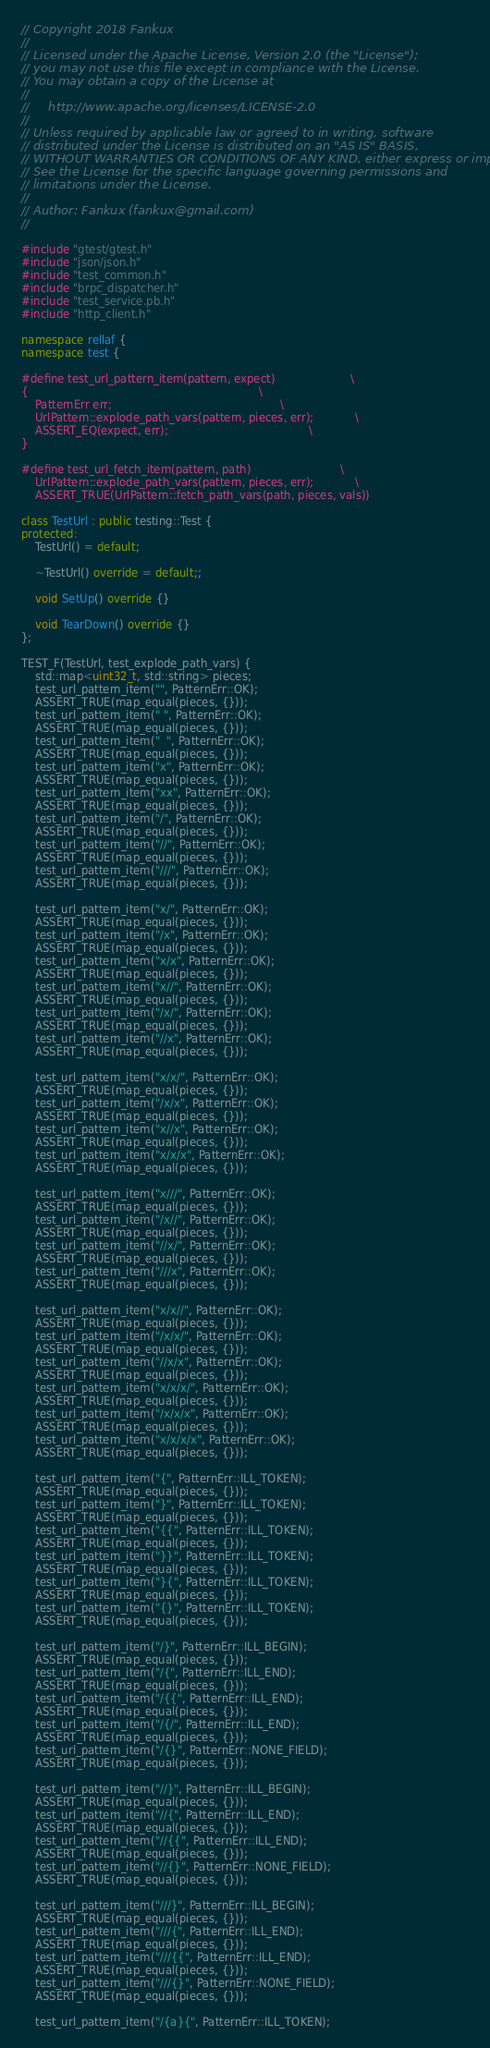<code> <loc_0><loc_0><loc_500><loc_500><_C++_>// Copyright 2018 Fankux
//
// Licensed under the Apache License, Version 2.0 (the "License");
// you may not use this file except in compliance with the License.
// You may obtain a copy of the License at
//
//     http://www.apache.org/licenses/LICENSE-2.0
//
// Unless required by applicable law or agreed to in writing, software
// distributed under the License is distributed on an "AS IS" BASIS,
// WITHOUT WARRANTIES OR CONDITIONS OF ANY KIND, either express or implied.
// See the License for the specific language governing permissions and
// limitations under the License.
//
// Author: Fankux (fankux@gmail.com)
//

#include "gtest/gtest.h"
#include "json/json.h"
#include "test_common.h"
#include "brpc_dispatcher.h"
#include "test_service.pb.h"
#include "http_client.h"

namespace rellaf {
namespace test {

#define test_url_pattern_item(pattern, expect)                      \
{                                                                   \
    PatternErr err;                                                 \
    UrlPattern::explode_path_vars(pattern, pieces, err);            \
    ASSERT_EQ(expect, err);                                         \
}

#define test_url_fetch_item(pattern, path)                          \
    UrlPattern::explode_path_vars(pattern, pieces, err);            \
    ASSERT_TRUE(UrlPattern::fetch_path_vars(path, pieces, vals))

class TestUrl : public testing::Test {
protected:
    TestUrl() = default;

    ~TestUrl() override = default;;

    void SetUp() override {}

    void TearDown() override {}
};

TEST_F(TestUrl, test_explode_path_vars) {
    std::map<uint32_t, std::string> pieces;
    test_url_pattern_item("", PatternErr::OK);
    ASSERT_TRUE(map_equal(pieces, {}));
    test_url_pattern_item(" ", PatternErr::OK);
    ASSERT_TRUE(map_equal(pieces, {}));
    test_url_pattern_item("  ", PatternErr::OK);
    ASSERT_TRUE(map_equal(pieces, {}));
    test_url_pattern_item("x", PatternErr::OK);
    ASSERT_TRUE(map_equal(pieces, {}));
    test_url_pattern_item("xx", PatternErr::OK);
    ASSERT_TRUE(map_equal(pieces, {}));
    test_url_pattern_item("/", PatternErr::OK);
    ASSERT_TRUE(map_equal(pieces, {}));
    test_url_pattern_item("//", PatternErr::OK);
    ASSERT_TRUE(map_equal(pieces, {}));
    test_url_pattern_item("///", PatternErr::OK);
    ASSERT_TRUE(map_equal(pieces, {}));

    test_url_pattern_item("x/", PatternErr::OK);
    ASSERT_TRUE(map_equal(pieces, {}));
    test_url_pattern_item("/x", PatternErr::OK);
    ASSERT_TRUE(map_equal(pieces, {}));
    test_url_pattern_item("x/x", PatternErr::OK);
    ASSERT_TRUE(map_equal(pieces, {}));
    test_url_pattern_item("x//", PatternErr::OK);
    ASSERT_TRUE(map_equal(pieces, {}));
    test_url_pattern_item("/x/", PatternErr::OK);
    ASSERT_TRUE(map_equal(pieces, {}));
    test_url_pattern_item("//x", PatternErr::OK);
    ASSERT_TRUE(map_equal(pieces, {}));

    test_url_pattern_item("x/x/", PatternErr::OK);
    ASSERT_TRUE(map_equal(pieces, {}));
    test_url_pattern_item("/x/x", PatternErr::OK);
    ASSERT_TRUE(map_equal(pieces, {}));
    test_url_pattern_item("x//x", PatternErr::OK);
    ASSERT_TRUE(map_equal(pieces, {}));
    test_url_pattern_item("x/x/x", PatternErr::OK);
    ASSERT_TRUE(map_equal(pieces, {}));

    test_url_pattern_item("x///", PatternErr::OK);
    ASSERT_TRUE(map_equal(pieces, {}));
    test_url_pattern_item("/x//", PatternErr::OK);
    ASSERT_TRUE(map_equal(pieces, {}));
    test_url_pattern_item("//x/", PatternErr::OK);
    ASSERT_TRUE(map_equal(pieces, {}));
    test_url_pattern_item("///x", PatternErr::OK);
    ASSERT_TRUE(map_equal(pieces, {}));

    test_url_pattern_item("x/x//", PatternErr::OK);
    ASSERT_TRUE(map_equal(pieces, {}));
    test_url_pattern_item("/x/x/", PatternErr::OK);
    ASSERT_TRUE(map_equal(pieces, {}));
    test_url_pattern_item("//x/x", PatternErr::OK);
    ASSERT_TRUE(map_equal(pieces, {}));
    test_url_pattern_item("x/x/x/", PatternErr::OK);
    ASSERT_TRUE(map_equal(pieces, {}));
    test_url_pattern_item("/x/x/x", PatternErr::OK);
    ASSERT_TRUE(map_equal(pieces, {}));
    test_url_pattern_item("x/x/x/x", PatternErr::OK);
    ASSERT_TRUE(map_equal(pieces, {}));

    test_url_pattern_item("{", PatternErr::ILL_TOKEN);
    ASSERT_TRUE(map_equal(pieces, {}));
    test_url_pattern_item("}", PatternErr::ILL_TOKEN);
    ASSERT_TRUE(map_equal(pieces, {}));
    test_url_pattern_item("{{", PatternErr::ILL_TOKEN);
    ASSERT_TRUE(map_equal(pieces, {}));
    test_url_pattern_item("}}", PatternErr::ILL_TOKEN);
    ASSERT_TRUE(map_equal(pieces, {}));
    test_url_pattern_item("}{", PatternErr::ILL_TOKEN);
    ASSERT_TRUE(map_equal(pieces, {}));
    test_url_pattern_item("{}", PatternErr::ILL_TOKEN);
    ASSERT_TRUE(map_equal(pieces, {}));

    test_url_pattern_item("/}", PatternErr::ILL_BEGIN);
    ASSERT_TRUE(map_equal(pieces, {}));
    test_url_pattern_item("/{", PatternErr::ILL_END);
    ASSERT_TRUE(map_equal(pieces, {}));
    test_url_pattern_item("/{{", PatternErr::ILL_END);
    ASSERT_TRUE(map_equal(pieces, {}));
    test_url_pattern_item("/{/", PatternErr::ILL_END);
    ASSERT_TRUE(map_equal(pieces, {}));
    test_url_pattern_item("/{}", PatternErr::NONE_FIELD);
    ASSERT_TRUE(map_equal(pieces, {}));

    test_url_pattern_item("//}", PatternErr::ILL_BEGIN);
    ASSERT_TRUE(map_equal(pieces, {}));
    test_url_pattern_item("//{", PatternErr::ILL_END);
    ASSERT_TRUE(map_equal(pieces, {}));
    test_url_pattern_item("//{{", PatternErr::ILL_END);
    ASSERT_TRUE(map_equal(pieces, {}));
    test_url_pattern_item("//{}", PatternErr::NONE_FIELD);
    ASSERT_TRUE(map_equal(pieces, {}));

    test_url_pattern_item("///}", PatternErr::ILL_BEGIN);
    ASSERT_TRUE(map_equal(pieces, {}));
    test_url_pattern_item("///{", PatternErr::ILL_END);
    ASSERT_TRUE(map_equal(pieces, {}));
    test_url_pattern_item("///{{", PatternErr::ILL_END);
    ASSERT_TRUE(map_equal(pieces, {}));
    test_url_pattern_item("///{}", PatternErr::NONE_FIELD);
    ASSERT_TRUE(map_equal(pieces, {}));

    test_url_pattern_item("/{a}{", PatternErr::ILL_TOKEN);</code> 